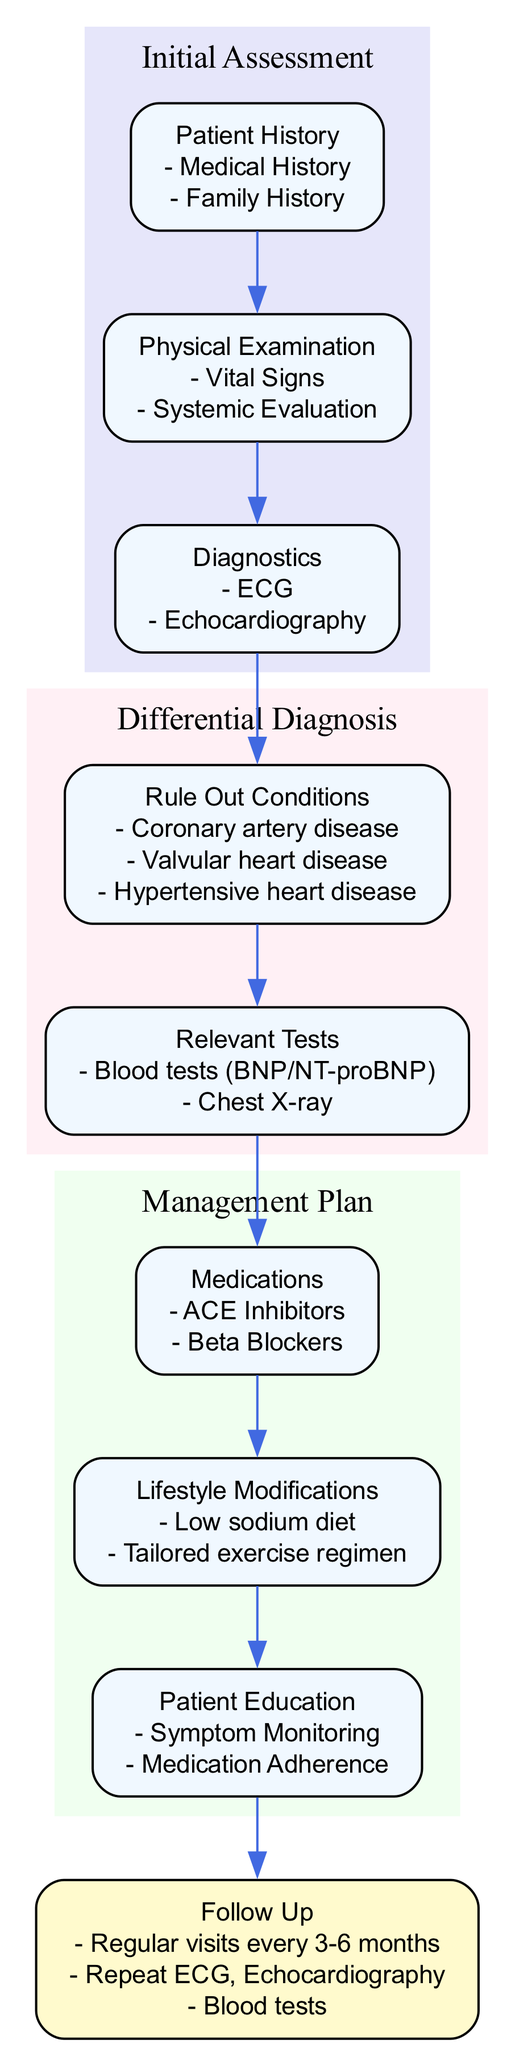What is the first step in the clinical pathway? The first step in the clinical pathway is "Initial Assessment." This step contains the initial evaluation of the patient which leads to further steps in the management of heart failure.
Answer: Initial Assessment How many main clusters are present in the diagram? The diagram has four main clusters: Initial Assessment, Differential Diagnosis, Management Plan, and Follow Up. Each cluster represents a distinct phase in the clinical pathway.
Answer: 4 What test is performed to assess heart rhythm? The test performed to assess heart rhythm is the ECG (electrocardiogram). It is a critical diagnostic step under the Initial Assessment section of the pathway.
Answer: ECG Which medication should be started or adjusted in the Management Plan? The medication that should be started or adjusted is ACE Inhibitors. It is part of the Management Plan focusing on pharmacological treatment for heart failure.
Answer: ACE Inhibitors What lifestyle modification is recommended? The recommended lifestyle modification is a low sodium diet. This is part of the Management Plan aimed at improving health outcomes for patients with heart failure.
Answer: Low sodium diet Which two tests are listed under Relevant Tests in Differential Diagnosis? The two tests listed under Relevant Tests are blood tests (BNP/NT-proBNP) and chest X-ray. Both tests are essential for identifying conditions contributing to heart failure.
Answer: Blood tests (BNP/NT-proBNP), Chest X-ray What is the frequency of regular follow-up visits? Regular follow-up visits are scheduled every 3-6 months. This timing is emphasized in the Follow Up section of the pathway to ensure ongoing patient management.
Answer: Every 3-6 months What is included in Patient Education? Patient Education includes symptom monitoring and medication adherence. These components are essential for empowering patients in the management of their condition.
Answer: Symptom Monitoring, Medication Adherence Which cluster includes the assessment of vital signs? The assessment of vital signs is included in the Physical Examination cluster, which is part of the Initial Assessment phase that evaluates the patient's current state.
Answer: Physical Examination 